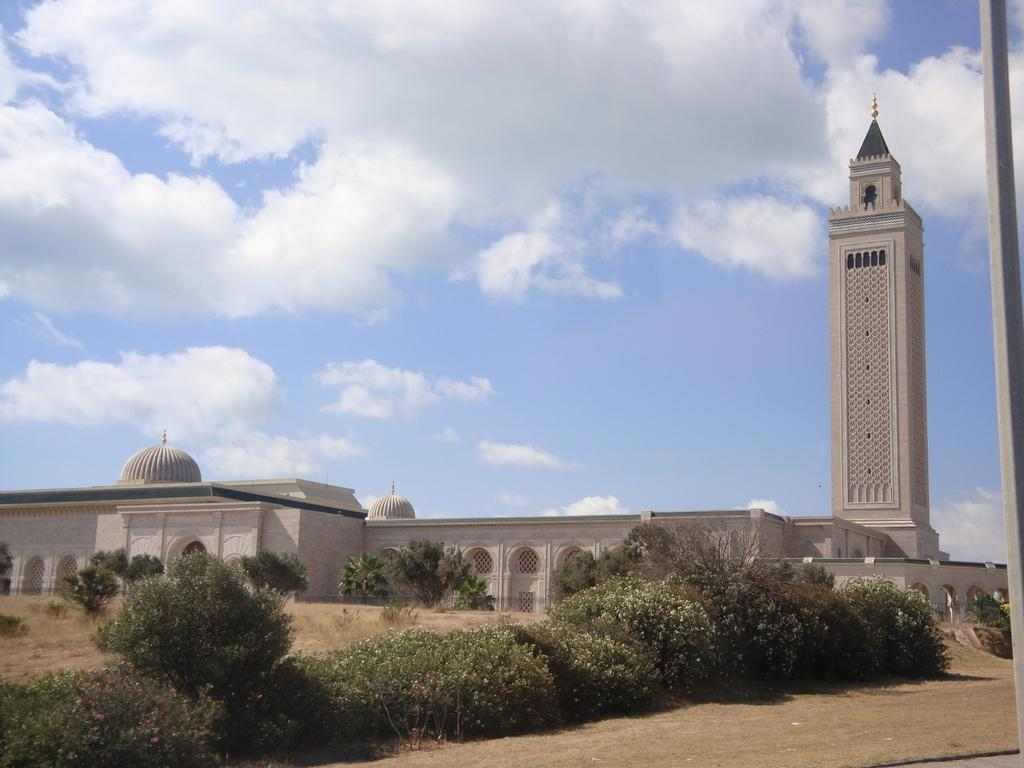What can be seen in the sky in the image? The sky with clouds is visible in the image. What is the tall structure in the image? There is a tower in the image. What type of man-made structures are present in the image? There are buildings in the image. What type of vegetation can be seen in the image? Trees and bushes are visible in the image. What is the surface on which the other elements are placed or situated? The ground is visible in the image. What is the purpose of the cave in the image? There is no cave present in the image. What does the mother do in the image? There is no mother or any human figure present in the image. 